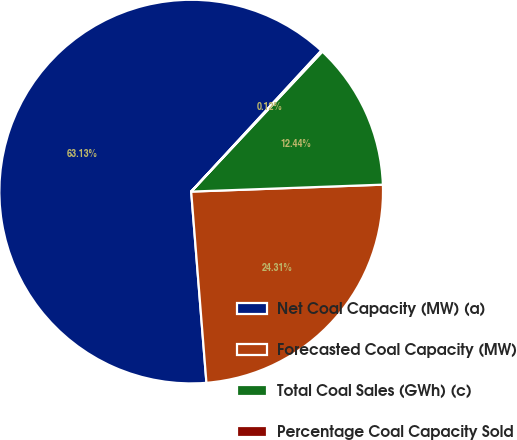Convert chart to OTSL. <chart><loc_0><loc_0><loc_500><loc_500><pie_chart><fcel>Net Coal Capacity (MW) (a)<fcel>Forecasted Coal Capacity (MW)<fcel>Total Coal Sales (GWh) (c)<fcel>Percentage Coal Capacity Sold<nl><fcel>63.13%<fcel>24.31%<fcel>12.44%<fcel>0.12%<nl></chart> 